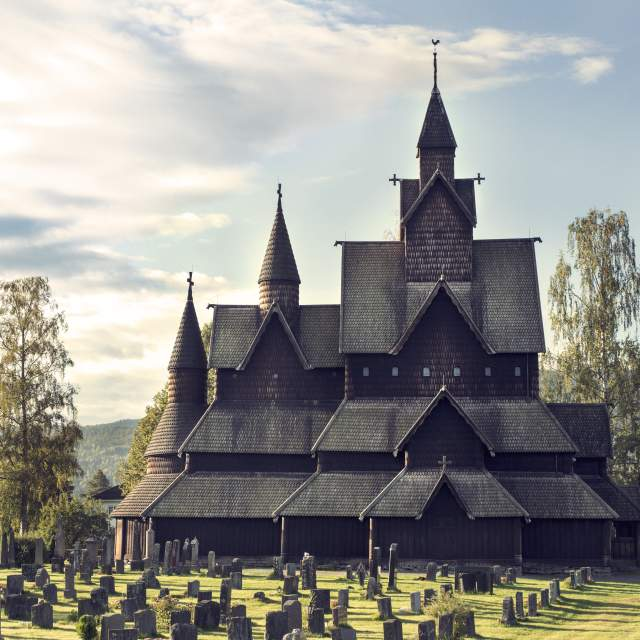Imagine attending a winter solstice celebration at this church. What would that be like? Attending a winter solstice celebration at Heddal Stave Church would be a deeply atmospheric and mystical experience. As the shortest day of the year gives way to longer nights, the church and its surroundings would be cloaked in snow, the dark wood contrasting beautifully against the white landscape. Flickering candlelights and warm lanterns would illuminate the church’s intricate carvings, casting a magical glow. The air would be crisp, filled with the scents of pine and winter spices. The community, wrapped in warm blankets and traditional attire, would gather to celebrate the rebirth of the sun with singing, storytelling, and perhaps a hearty feast indoors. The haunting melodies of ancient hymns would resonate through the wooden halls, connecting the present with the traditions of centuries past. 